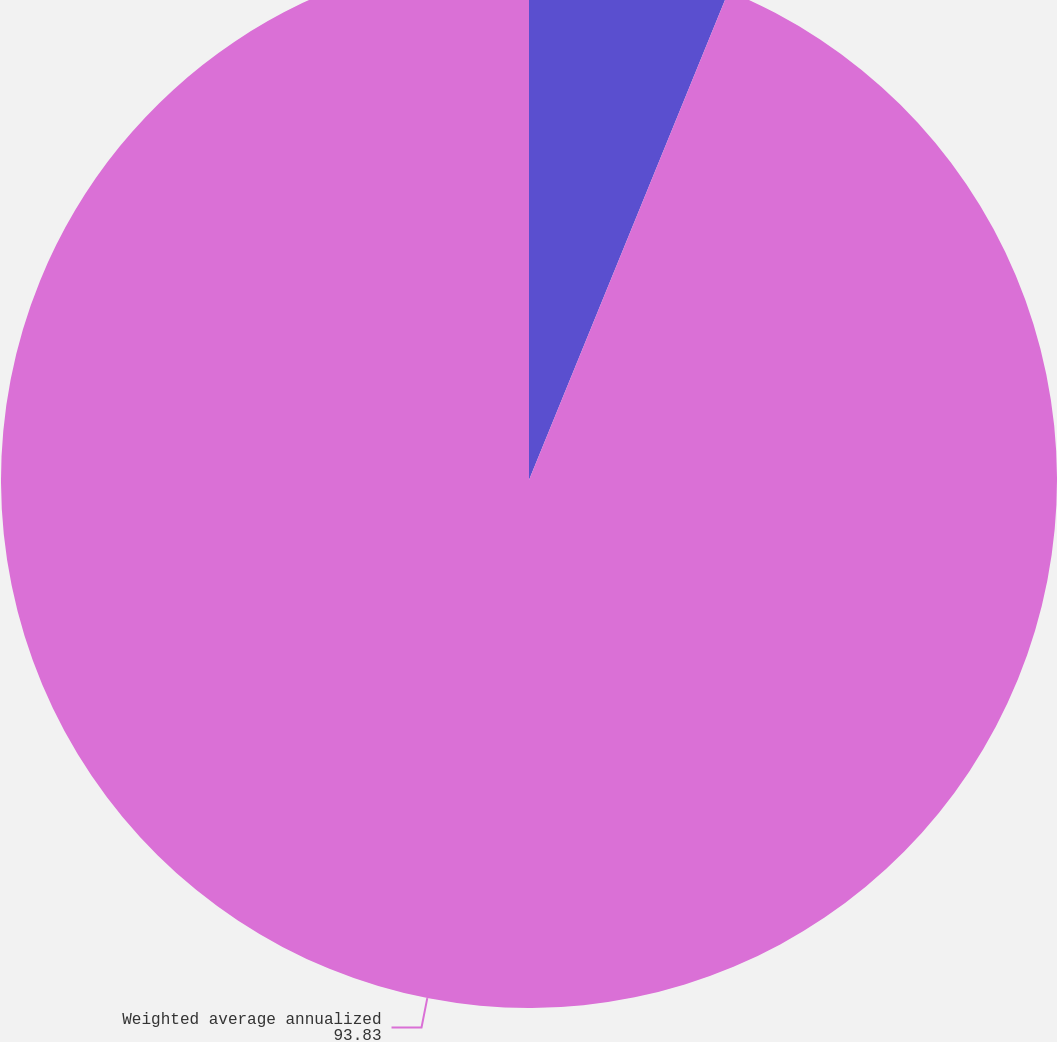Convert chart to OTSL. <chart><loc_0><loc_0><loc_500><loc_500><pie_chart><fcel>Expected dividend yield<fcel>Weighted average annualized<nl><fcel>6.17%<fcel>93.83%<nl></chart> 